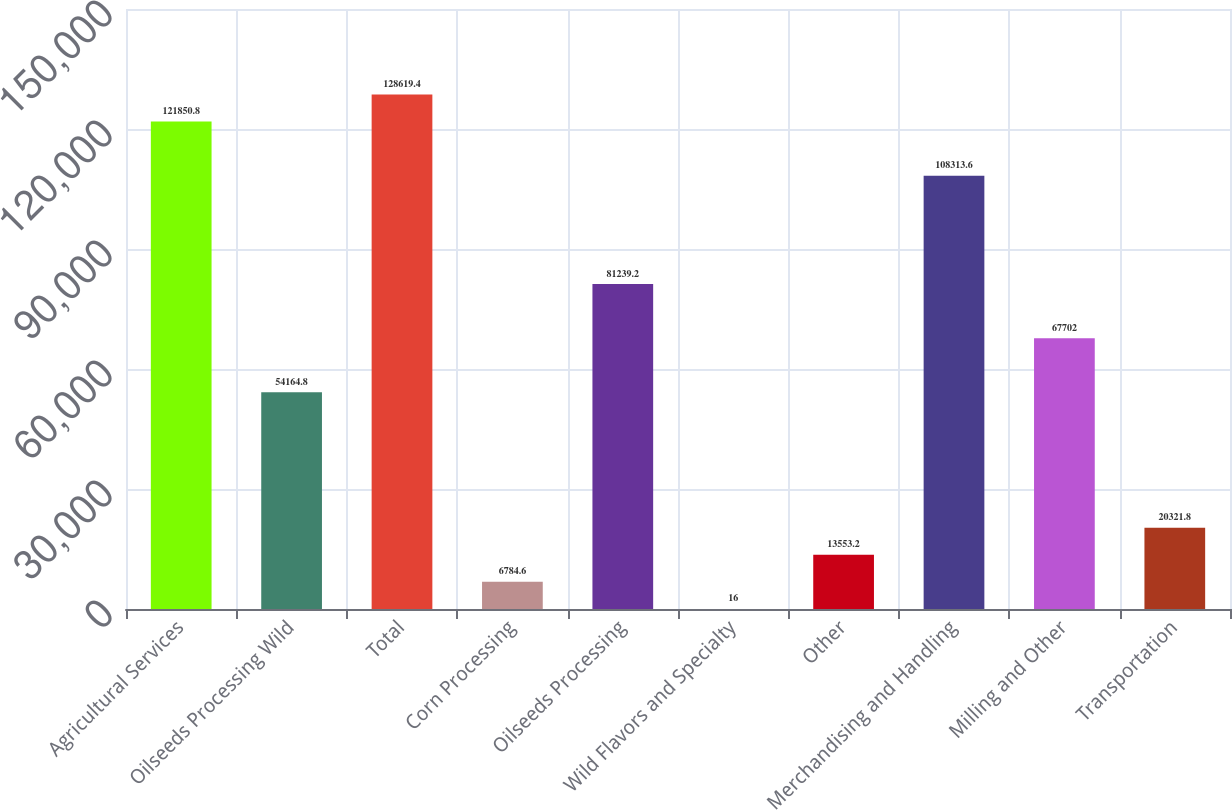Convert chart to OTSL. <chart><loc_0><loc_0><loc_500><loc_500><bar_chart><fcel>Agricultural Services<fcel>Oilseeds Processing Wild<fcel>Total<fcel>Corn Processing<fcel>Oilseeds Processing<fcel>Wild Flavors and Specialty<fcel>Other<fcel>Merchandising and Handling<fcel>Milling and Other<fcel>Transportation<nl><fcel>121851<fcel>54164.8<fcel>128619<fcel>6784.6<fcel>81239.2<fcel>16<fcel>13553.2<fcel>108314<fcel>67702<fcel>20321.8<nl></chart> 